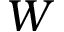Convert formula to latex. <formula><loc_0><loc_0><loc_500><loc_500>W</formula> 